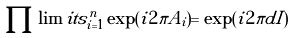Convert formula to latex. <formula><loc_0><loc_0><loc_500><loc_500>\prod \lim i t s _ { i = 1 } ^ { n } \exp ( i 2 \pi A _ { i } ) = \exp ( i 2 \pi d I )</formula> 